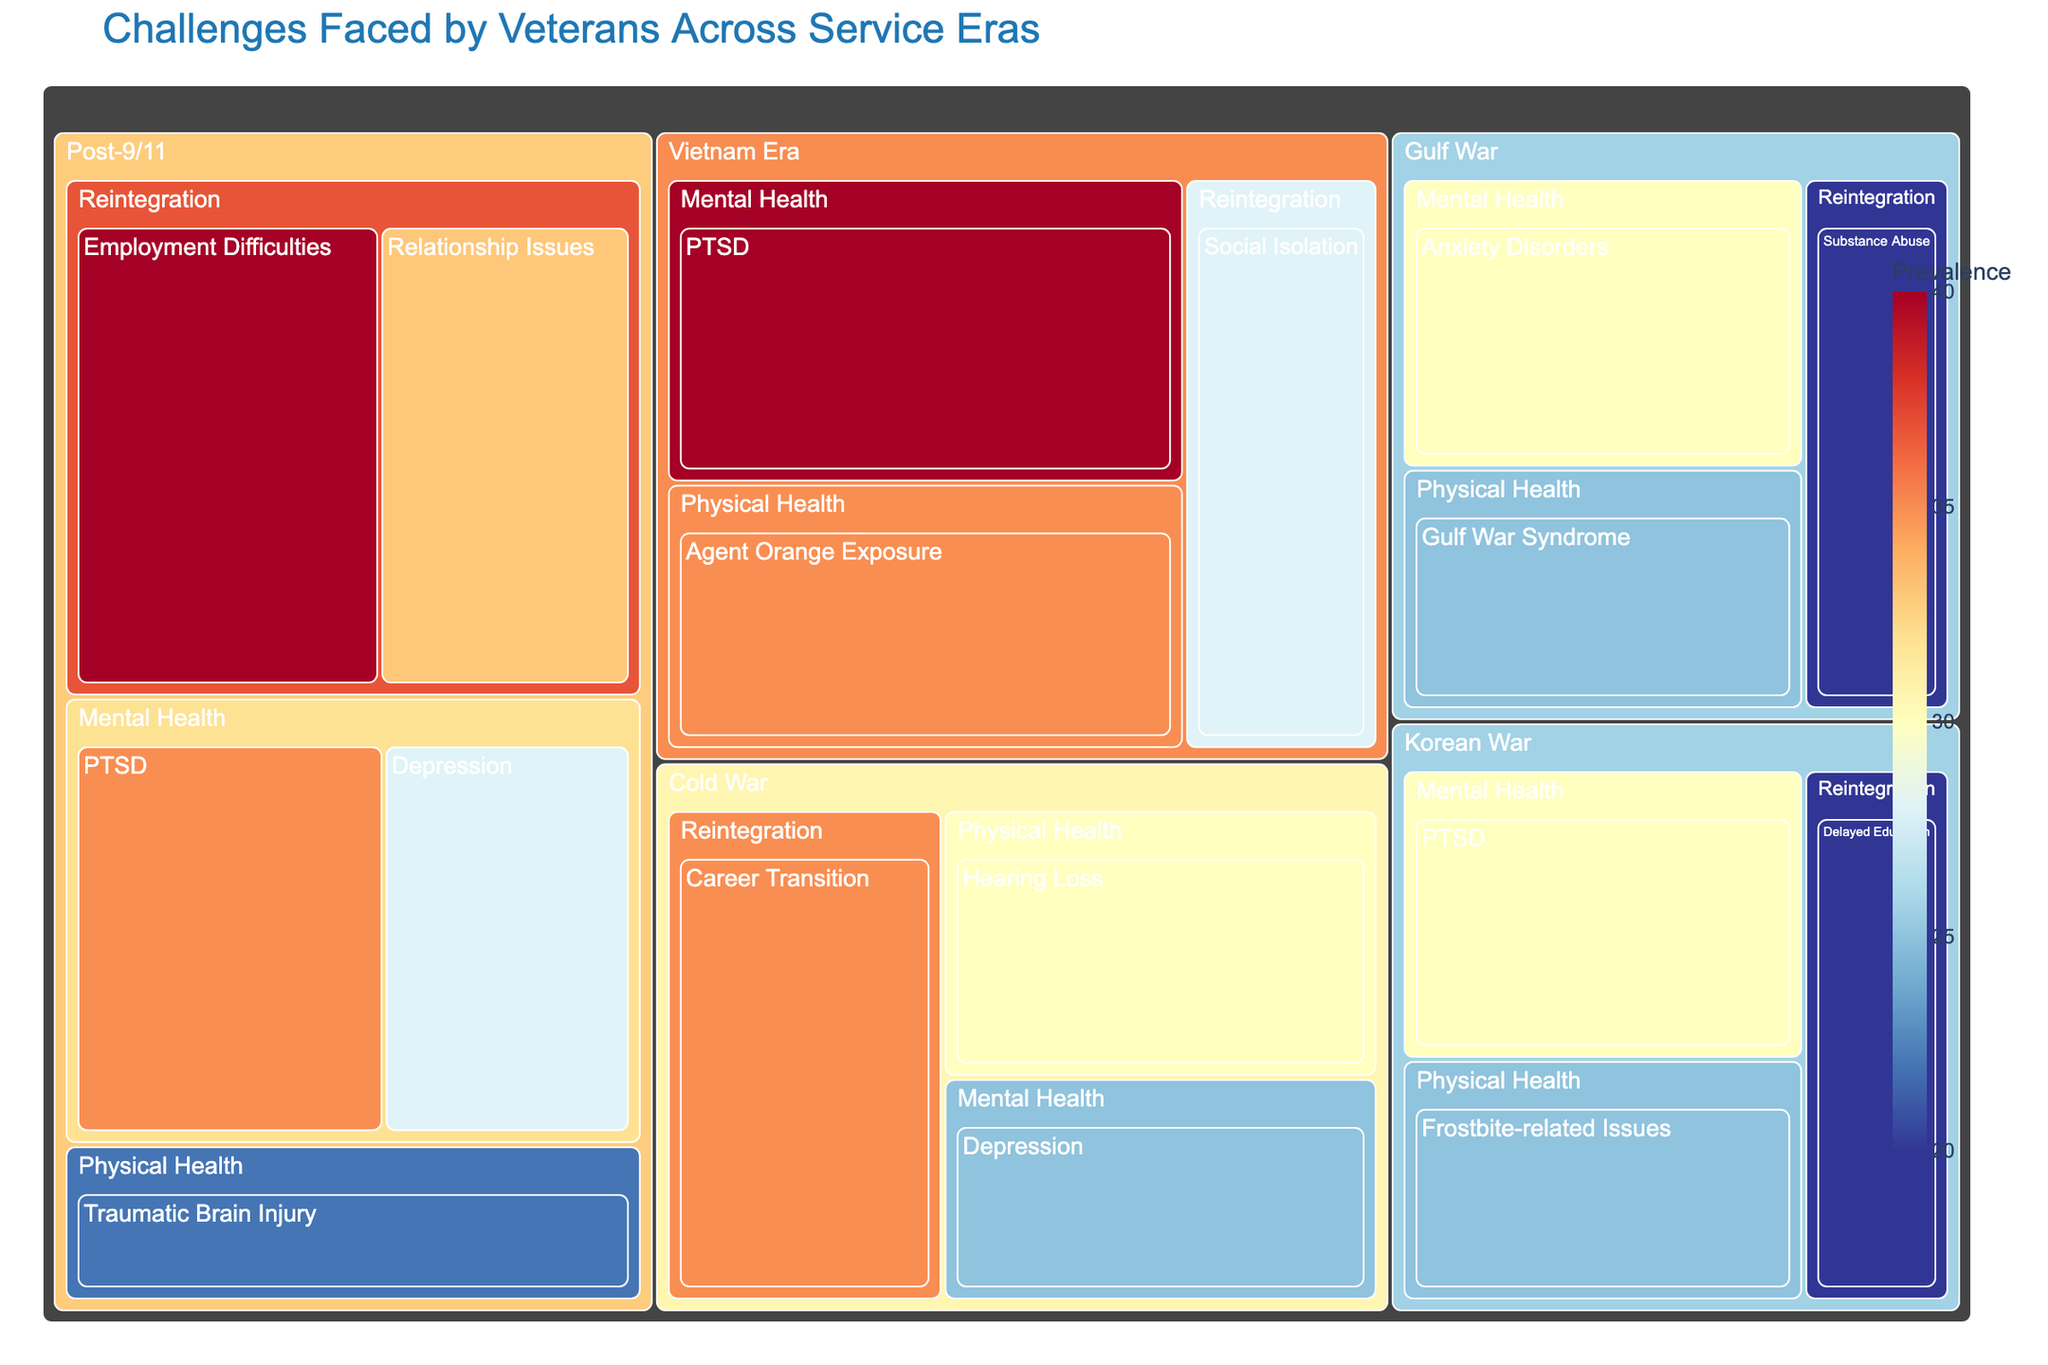What's the title of the Treemap? The title of the Treemap is located at the top and indicates the main subject of the visualization.
Answer: Challenges Faced by Veterans Across Service Eras How many categories of challenges are displayed for the Post-9/11 service era? By examining the sections under the Post-9/11 service era, we can count the distinct categories.
Answer: Three Which challenge has the highest prevalence in the Post-9/11 service era? Look at the Post-9/11 service era section and identify the challenge with the largest value of prevalence.
Answer: Employment Difficulties What is the combined prevalence of Mental Health challenges for the Gulf War era? Sum the prevalence values for Mental Health challenges in the Gulf War era: Anxiety Disorders.
Answer: 30 Which service era has the greatest prevalence of PTSD? Compare the prevalence values of PTSD across different service eras and identify the highest one.
Answer: Vietnam Era Among the physical health challenges, which era faces Agent Orange Exposure, and what is its prevalence? Search under the Physical Health category to find Agent Orange Exposure and note its service era and prevalence.
Answer: Vietnam Era, 35 How does the prevalence of PTSD in the Korean War era compare to that in the Post-9/11 era? Identify the prevalence values for PTSD in both eras and compare them directly.
Answer: Korean War is 30%, Post-9/11 is 35% What is the least prevalent challenge in the Vietnam Era service era? Look for the challenge with the smallest prevalence value in the Vietnam Era.
Answer: Social Isolation What's the difference in prevalence between Relationship Issues for Post-9/11 service members and Career Transition for Cold War service members? Subtract the prevalence value of Relationship Issues (Post-9/11) from Career Transition (Cold War).
Answer: 35 - 33 = 2 Which service era has the broadest range of categories covered? By examining the treemap, identify the service era with most distinct categories represented.
Answer: Post-9/11 